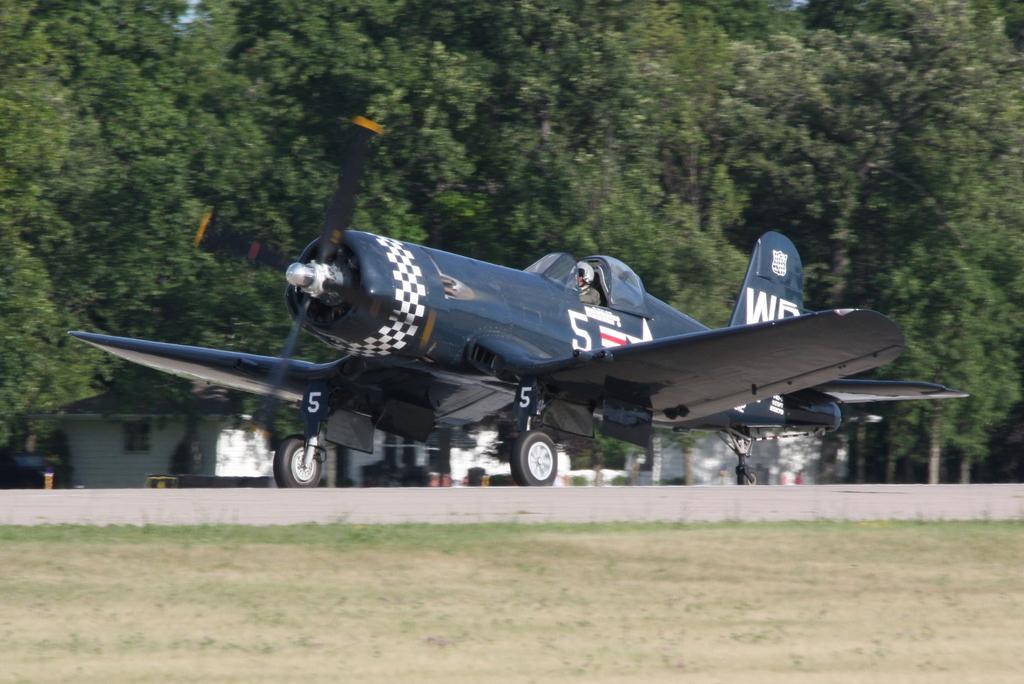Please provide a concise description of this image. This picture is clicked outside. In the center we can see a person and an aircraft seems to be running on the road and we can see the green grass, trees, house and some other objects. 